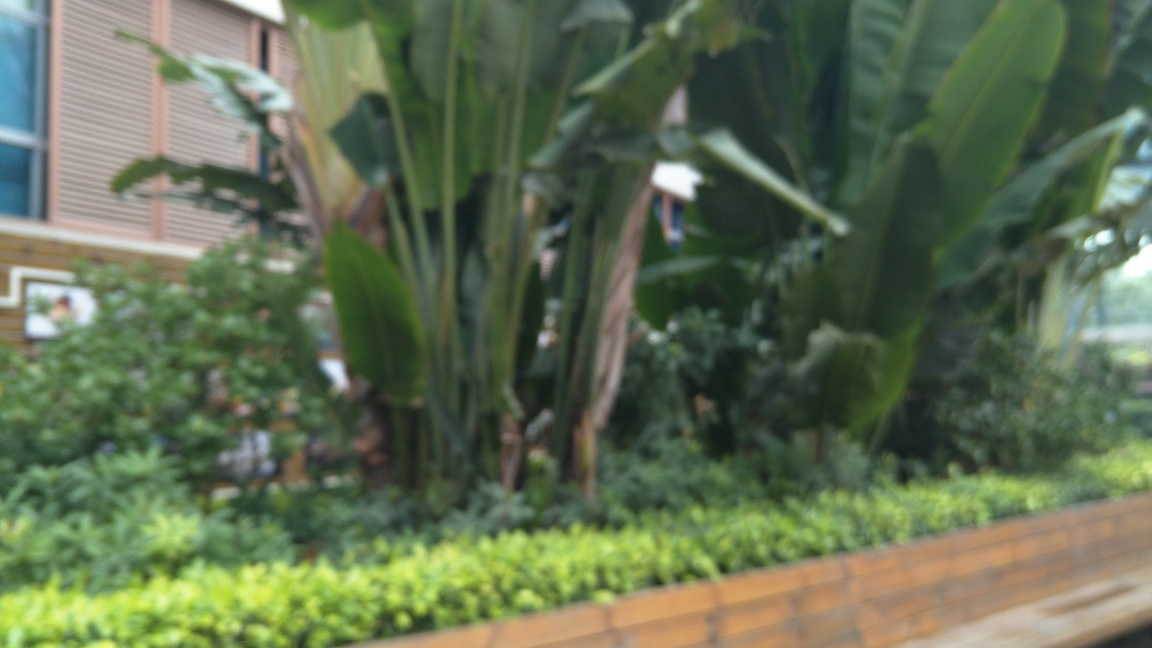Can you make out any man-made structures in this image or is it solely nature? Despite the blur, it's possible to make out the edge of a man-made structure behind the greenery, characterized by straight vertical lines and geometric forms that contrast with the organic shapes of the plants. It looks like a building facade or a fence that is in the background of this garden scene. 